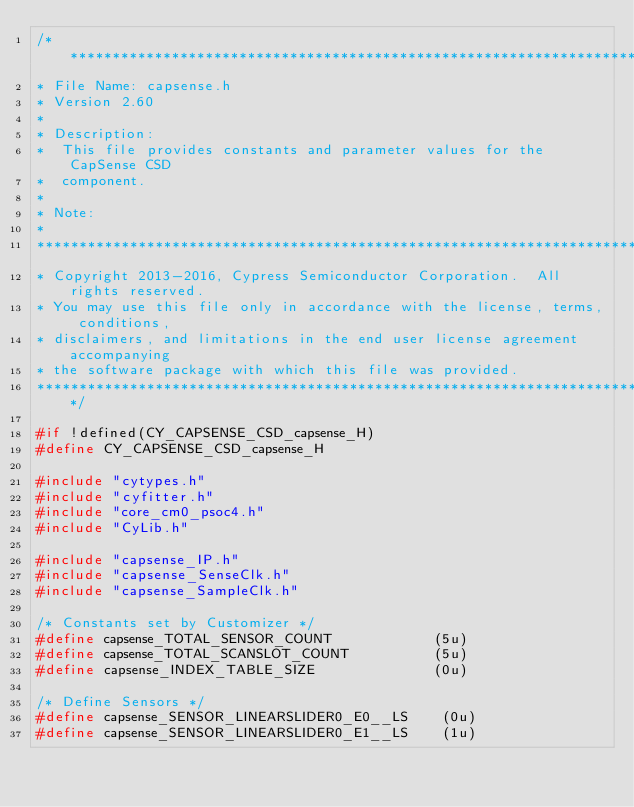<code> <loc_0><loc_0><loc_500><loc_500><_C_>/*******************************************************************************
* File Name: capsense.h
* Version 2.60
*
* Description:
*  This file provides constants and parameter values for the CapSense CSD
*  component.
*
* Note:
*
********************************************************************************
* Copyright 2013-2016, Cypress Semiconductor Corporation.  All rights reserved.
* You may use this file only in accordance with the license, terms, conditions,
* disclaimers, and limitations in the end user license agreement accompanying
* the software package with which this file was provided.
*******************************************************************************/

#if !defined(CY_CAPSENSE_CSD_capsense_H)
#define CY_CAPSENSE_CSD_capsense_H

#include "cytypes.h"
#include "cyfitter.h"
#include "core_cm0_psoc4.h"
#include "CyLib.h"

#include "capsense_IP.h"
#include "capsense_SenseClk.h"
#include "capsense_SampleClk.h"

/* Constants set by Customizer */
#define capsense_TOTAL_SENSOR_COUNT            (5u)
#define capsense_TOTAL_SCANSLOT_COUNT          (5u)
#define capsense_INDEX_TABLE_SIZE              (0u)

/* Define Sensors */
#define capsense_SENSOR_LINEARSLIDER0_E0__LS    (0u)
#define capsense_SENSOR_LINEARSLIDER0_E1__LS    (1u)</code> 